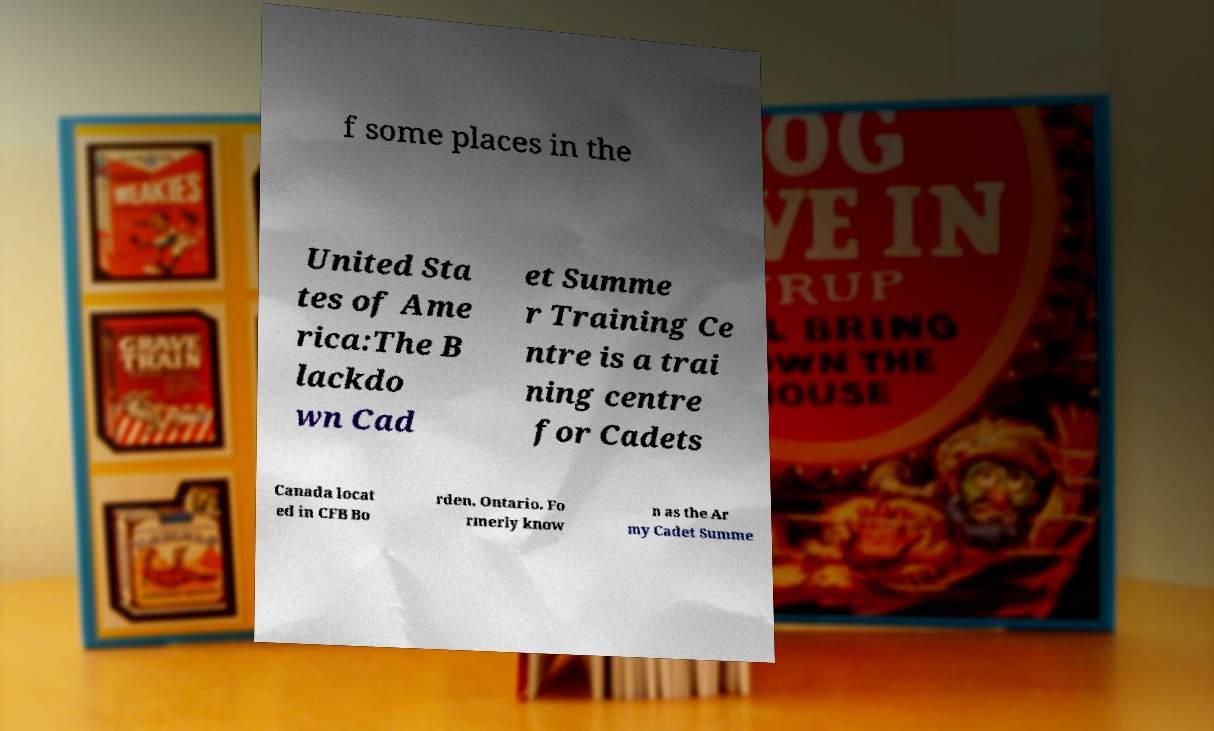Can you accurately transcribe the text from the provided image for me? f some places in the United Sta tes of Ame rica:The B lackdo wn Cad et Summe r Training Ce ntre is a trai ning centre for Cadets Canada locat ed in CFB Bo rden, Ontario. Fo rmerly know n as the Ar my Cadet Summe 